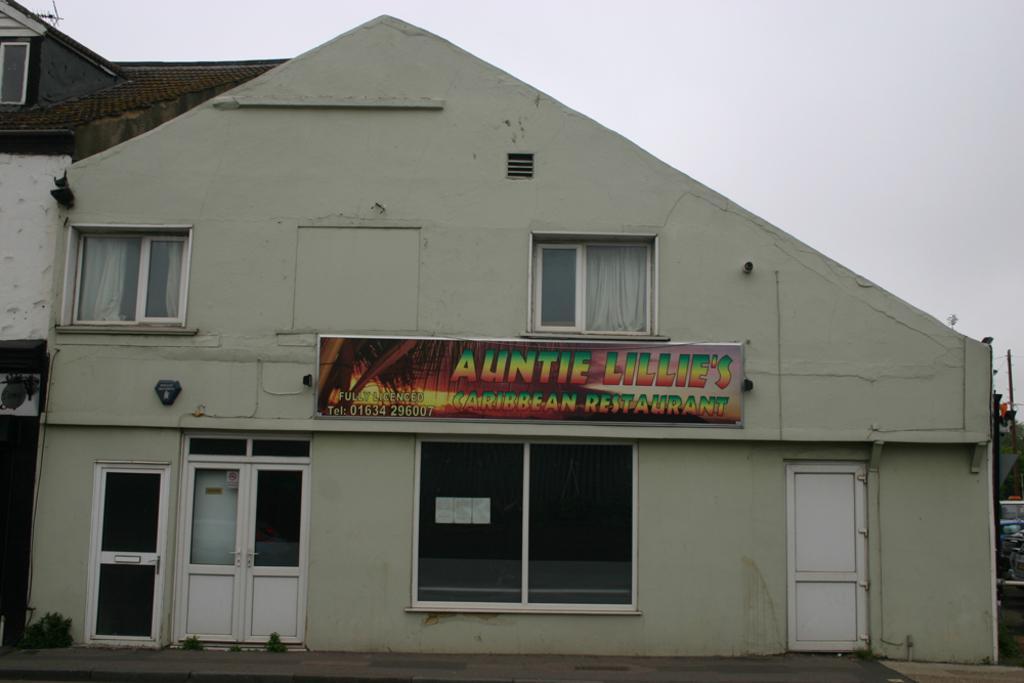Please provide a concise description of this image. Here we can see a building, board, windows, curtains, and doors. In the background there is sky. 